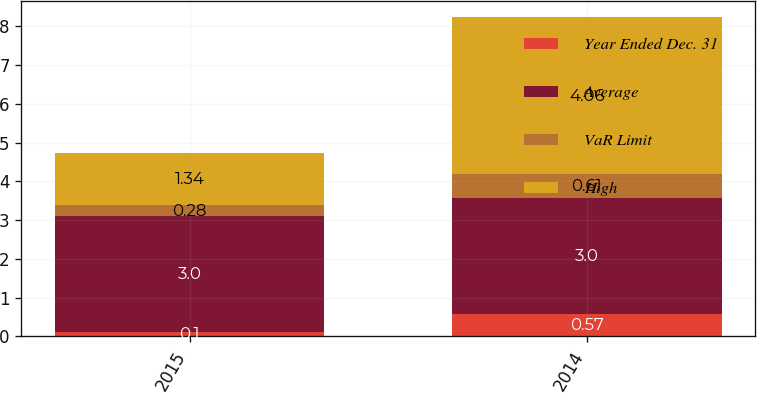<chart> <loc_0><loc_0><loc_500><loc_500><stacked_bar_chart><ecel><fcel>2015<fcel>2014<nl><fcel>Year Ended Dec. 31<fcel>0.1<fcel>0.57<nl><fcel>Average<fcel>3<fcel>3<nl><fcel>VaR Limit<fcel>0.28<fcel>0.61<nl><fcel>High<fcel>1.34<fcel>4.06<nl></chart> 